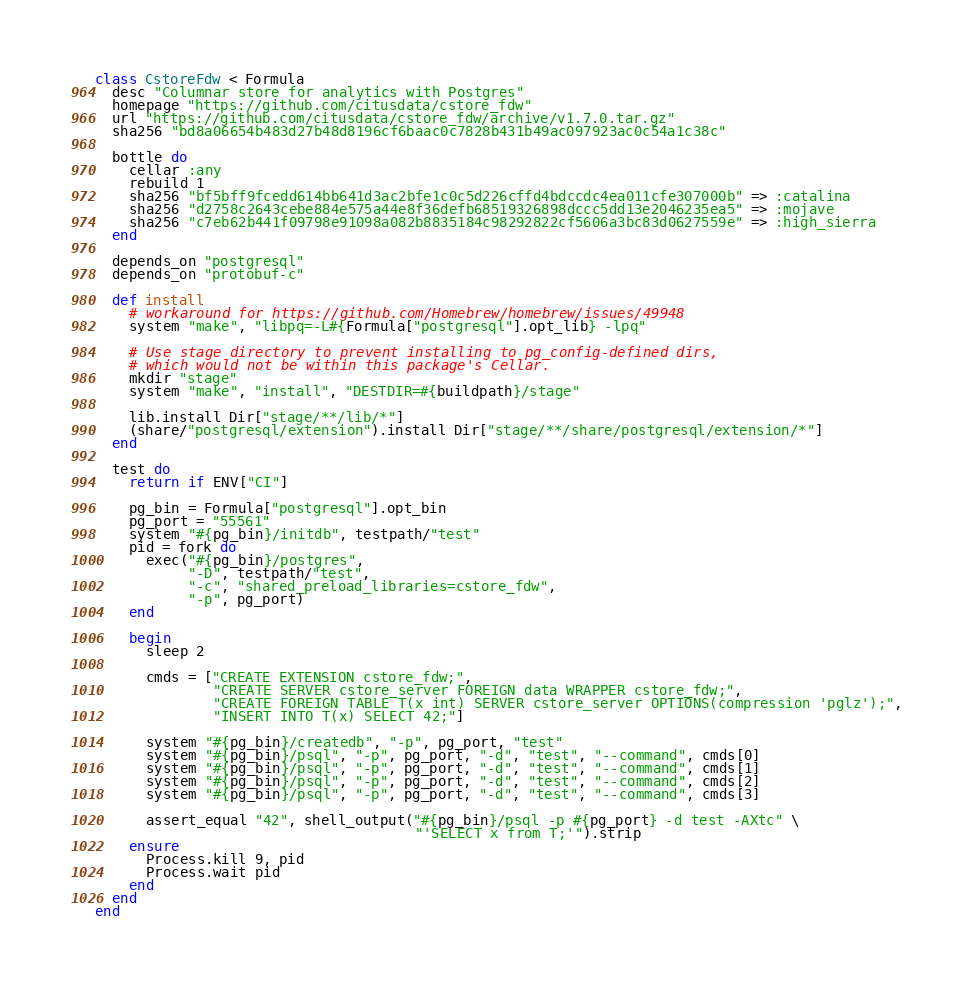Convert code to text. <code><loc_0><loc_0><loc_500><loc_500><_Ruby_>class CstoreFdw < Formula
  desc "Columnar store for analytics with Postgres"
  homepage "https://github.com/citusdata/cstore_fdw"
  url "https://github.com/citusdata/cstore_fdw/archive/v1.7.0.tar.gz"
  sha256 "bd8a06654b483d27b48d8196cf6baac0c7828b431b49ac097923ac0c54a1c38c"

  bottle do
    cellar :any
    rebuild 1
    sha256 "bf5bff9fcedd614bb641d3ac2bfe1c0c5d226cffd4bdccdc4ea011cfe307000b" => :catalina
    sha256 "d2758c2643cebe884e575a44e8f36defb68519326898dccc5dd13e2046235ea5" => :mojave
    sha256 "c7eb62b441f09798e91098a082b8835184c98292822cf5606a3bc83d0627559e" => :high_sierra
  end

  depends_on "postgresql"
  depends_on "protobuf-c"

  def install
    # workaround for https://github.com/Homebrew/homebrew/issues/49948
    system "make", "libpq=-L#{Formula["postgresql"].opt_lib} -lpq"

    # Use stage directory to prevent installing to pg_config-defined dirs,
    # which would not be within this package's Cellar.
    mkdir "stage"
    system "make", "install", "DESTDIR=#{buildpath}/stage"

    lib.install Dir["stage/**/lib/*"]
    (share/"postgresql/extension").install Dir["stage/**/share/postgresql/extension/*"]
  end

  test do
    return if ENV["CI"]

    pg_bin = Formula["postgresql"].opt_bin
    pg_port = "55561"
    system "#{pg_bin}/initdb", testpath/"test"
    pid = fork do
      exec("#{pg_bin}/postgres",
           "-D", testpath/"test",
           "-c", "shared_preload_libraries=cstore_fdw",
           "-p", pg_port)
    end

    begin
      sleep 2

      cmds = ["CREATE EXTENSION cstore_fdw;",
              "CREATE SERVER cstore_server FOREIGN data WRAPPER cstore_fdw;",
              "CREATE FOREIGN TABLE T(x int) SERVER cstore_server OPTIONS(compression 'pglz');",
              "INSERT INTO T(x) SELECT 42;"]

      system "#{pg_bin}/createdb", "-p", pg_port, "test"
      system "#{pg_bin}/psql", "-p", pg_port, "-d", "test", "--command", cmds[0]
      system "#{pg_bin}/psql", "-p", pg_port, "-d", "test", "--command", cmds[1]
      system "#{pg_bin}/psql", "-p", pg_port, "-d", "test", "--command", cmds[2]
      system "#{pg_bin}/psql", "-p", pg_port, "-d", "test", "--command", cmds[3]

      assert_equal "42", shell_output("#{pg_bin}/psql -p #{pg_port} -d test -AXtc" \
                                      "'SELECT x from T;'").strip
    ensure
      Process.kill 9, pid
      Process.wait pid
    end
  end
end
</code> 